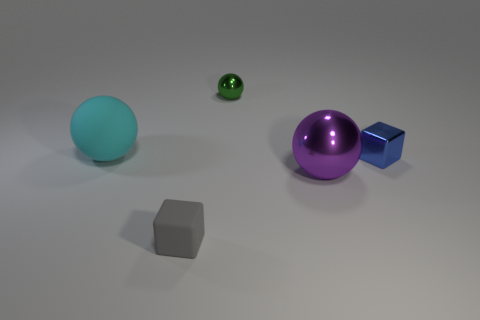There is a big cyan object that is the same material as the gray thing; what is its shape?
Give a very brief answer. Sphere. What is the color of the thing that is to the left of the tiny shiny sphere and to the right of the large cyan thing?
Offer a terse response. Gray. What is the size of the cube that is on the right side of the ball that is in front of the big cyan rubber sphere?
Your answer should be compact. Small. Are there any large objects that have the same color as the tiny shiny cube?
Ensure brevity in your answer.  No. Are there the same number of blue cubes to the left of the large cyan matte sphere and small blue shiny balls?
Your answer should be compact. Yes. How many large cyan shiny objects are there?
Offer a very short reply. 0. There is a thing that is to the left of the large purple ball and in front of the blue metallic thing; what is its shape?
Keep it short and to the point. Cube. Is the color of the shiny sphere that is on the right side of the tiny green object the same as the matte thing in front of the big cyan rubber object?
Your answer should be compact. No. Is there a big cyan sphere that has the same material as the tiny green sphere?
Your answer should be very brief. No. Are there the same number of small rubber things that are in front of the tiny gray matte block and small gray matte blocks that are behind the tiny blue block?
Your response must be concise. Yes. 